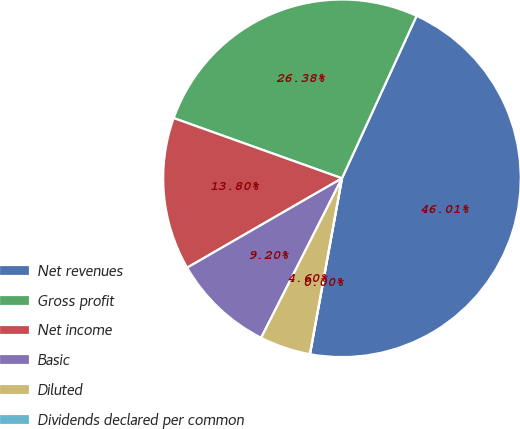<chart> <loc_0><loc_0><loc_500><loc_500><pie_chart><fcel>Net revenues<fcel>Gross profit<fcel>Net income<fcel>Basic<fcel>Diluted<fcel>Dividends declared per common<nl><fcel>46.01%<fcel>26.38%<fcel>13.8%<fcel>9.2%<fcel>4.6%<fcel>0.0%<nl></chart> 